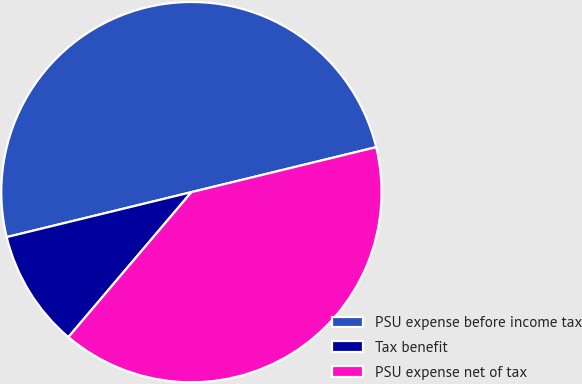Convert chart. <chart><loc_0><loc_0><loc_500><loc_500><pie_chart><fcel>PSU expense before income tax<fcel>Tax benefit<fcel>PSU expense net of tax<nl><fcel>50.0%<fcel>10.0%<fcel>40.0%<nl></chart> 